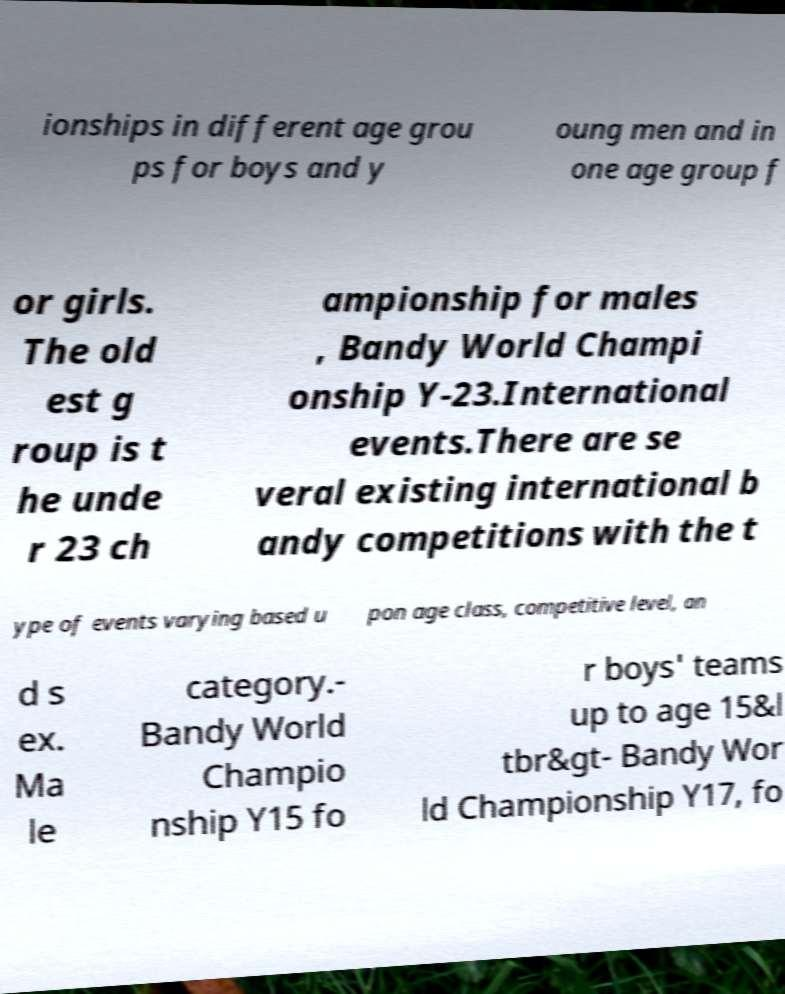Please read and relay the text visible in this image. What does it say? ionships in different age grou ps for boys and y oung men and in one age group f or girls. The old est g roup is t he unde r 23 ch ampionship for males , Bandy World Champi onship Y-23.International events.There are se veral existing international b andy competitions with the t ype of events varying based u pon age class, competitive level, an d s ex. Ma le category.- Bandy World Champio nship Y15 fo r boys' teams up to age 15&l tbr&gt- Bandy Wor ld Championship Y17, fo 